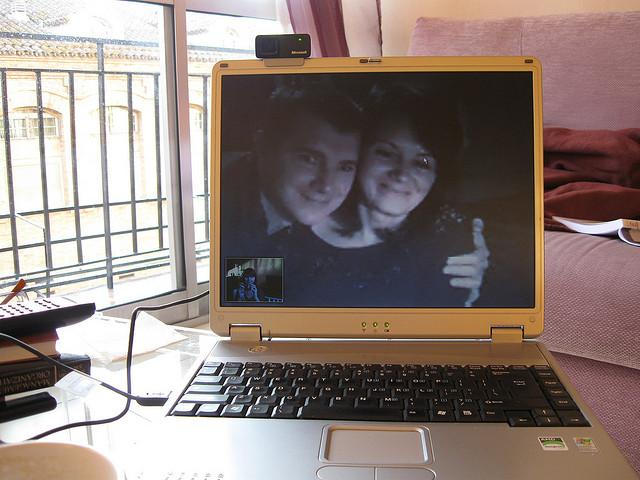Who is using this laptop?

Choices:
A) girl
B) woman
C) man
D) boy girl 